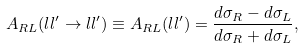Convert formula to latex. <formula><loc_0><loc_0><loc_500><loc_500>A _ { R L } ( l l ^ { \prime } \to l l ^ { \prime } ) \equiv A _ { R L } ( l l ^ { \prime } ) = \frac { d \sigma _ { R } - d \sigma _ { L } } { d \sigma _ { R } + d \sigma _ { L } } ,</formula> 